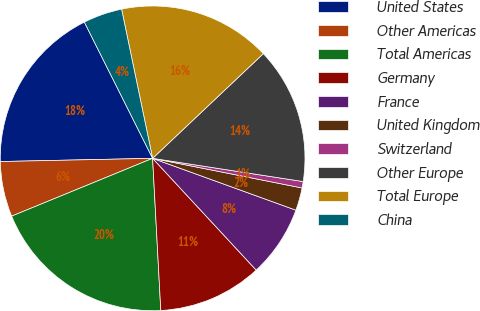Convert chart. <chart><loc_0><loc_0><loc_500><loc_500><pie_chart><fcel>United States<fcel>Other Americas<fcel>Total Americas<fcel>Germany<fcel>France<fcel>United Kingdom<fcel>Switzerland<fcel>Other Europe<fcel>Total Europe<fcel>China<nl><fcel>17.94%<fcel>5.86%<fcel>19.66%<fcel>11.04%<fcel>7.58%<fcel>2.41%<fcel>0.68%<fcel>14.49%<fcel>16.21%<fcel>4.13%<nl></chart> 